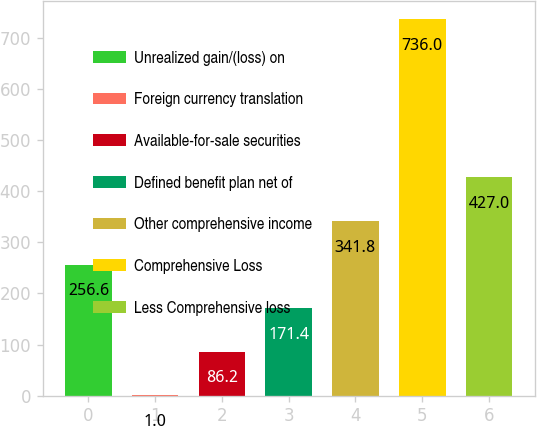<chart> <loc_0><loc_0><loc_500><loc_500><bar_chart><fcel>Unrealized gain/(loss) on<fcel>Foreign currency translation<fcel>Available-for-sale securities<fcel>Defined benefit plan net of<fcel>Other comprehensive income<fcel>Comprehensive Loss<fcel>Less Comprehensive loss<nl><fcel>256.6<fcel>1<fcel>86.2<fcel>171.4<fcel>341.8<fcel>736<fcel>427<nl></chart> 